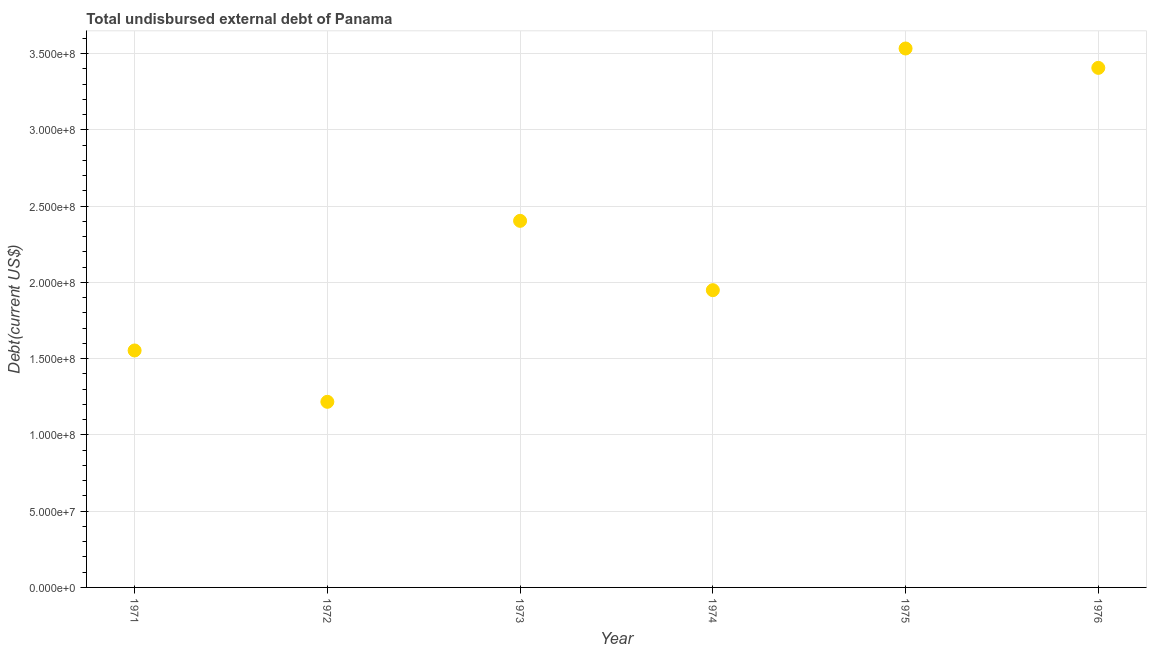What is the total debt in 1976?
Your answer should be very brief. 3.41e+08. Across all years, what is the maximum total debt?
Your answer should be compact. 3.53e+08. Across all years, what is the minimum total debt?
Your answer should be very brief. 1.22e+08. In which year was the total debt maximum?
Your answer should be compact. 1975. In which year was the total debt minimum?
Make the answer very short. 1972. What is the sum of the total debt?
Provide a short and direct response. 1.41e+09. What is the difference between the total debt in 1973 and 1976?
Give a very brief answer. -1.00e+08. What is the average total debt per year?
Offer a very short reply. 2.34e+08. What is the median total debt?
Ensure brevity in your answer.  2.18e+08. Do a majority of the years between 1974 and 1972 (inclusive) have total debt greater than 270000000 US$?
Ensure brevity in your answer.  No. What is the ratio of the total debt in 1973 to that in 1976?
Offer a very short reply. 0.71. Is the difference between the total debt in 1974 and 1975 greater than the difference between any two years?
Keep it short and to the point. No. What is the difference between the highest and the second highest total debt?
Offer a terse response. 1.27e+07. What is the difference between the highest and the lowest total debt?
Keep it short and to the point. 2.32e+08. In how many years, is the total debt greater than the average total debt taken over all years?
Your answer should be compact. 3. How many years are there in the graph?
Your response must be concise. 6. What is the difference between two consecutive major ticks on the Y-axis?
Your answer should be compact. 5.00e+07. Does the graph contain any zero values?
Offer a terse response. No. Does the graph contain grids?
Give a very brief answer. Yes. What is the title of the graph?
Your answer should be very brief. Total undisbursed external debt of Panama. What is the label or title of the Y-axis?
Give a very brief answer. Debt(current US$). What is the Debt(current US$) in 1971?
Keep it short and to the point. 1.55e+08. What is the Debt(current US$) in 1972?
Keep it short and to the point. 1.22e+08. What is the Debt(current US$) in 1973?
Your answer should be very brief. 2.40e+08. What is the Debt(current US$) in 1974?
Your answer should be very brief. 1.95e+08. What is the Debt(current US$) in 1975?
Offer a very short reply. 3.53e+08. What is the Debt(current US$) in 1976?
Your answer should be compact. 3.41e+08. What is the difference between the Debt(current US$) in 1971 and 1972?
Make the answer very short. 3.37e+07. What is the difference between the Debt(current US$) in 1971 and 1973?
Make the answer very short. -8.50e+07. What is the difference between the Debt(current US$) in 1971 and 1974?
Provide a short and direct response. -3.95e+07. What is the difference between the Debt(current US$) in 1971 and 1975?
Offer a very short reply. -1.98e+08. What is the difference between the Debt(current US$) in 1971 and 1976?
Your answer should be compact. -1.85e+08. What is the difference between the Debt(current US$) in 1972 and 1973?
Your response must be concise. -1.19e+08. What is the difference between the Debt(current US$) in 1972 and 1974?
Offer a terse response. -7.32e+07. What is the difference between the Debt(current US$) in 1972 and 1975?
Provide a succinct answer. -2.32e+08. What is the difference between the Debt(current US$) in 1972 and 1976?
Give a very brief answer. -2.19e+08. What is the difference between the Debt(current US$) in 1973 and 1974?
Your answer should be very brief. 4.54e+07. What is the difference between the Debt(current US$) in 1973 and 1975?
Ensure brevity in your answer.  -1.13e+08. What is the difference between the Debt(current US$) in 1973 and 1976?
Ensure brevity in your answer.  -1.00e+08. What is the difference between the Debt(current US$) in 1974 and 1975?
Offer a terse response. -1.58e+08. What is the difference between the Debt(current US$) in 1974 and 1976?
Ensure brevity in your answer.  -1.46e+08. What is the difference between the Debt(current US$) in 1975 and 1976?
Offer a very short reply. 1.27e+07. What is the ratio of the Debt(current US$) in 1971 to that in 1972?
Give a very brief answer. 1.28. What is the ratio of the Debt(current US$) in 1971 to that in 1973?
Your answer should be compact. 0.65. What is the ratio of the Debt(current US$) in 1971 to that in 1974?
Offer a terse response. 0.8. What is the ratio of the Debt(current US$) in 1971 to that in 1975?
Provide a succinct answer. 0.44. What is the ratio of the Debt(current US$) in 1971 to that in 1976?
Ensure brevity in your answer.  0.46. What is the ratio of the Debt(current US$) in 1972 to that in 1973?
Provide a succinct answer. 0.51. What is the ratio of the Debt(current US$) in 1972 to that in 1974?
Offer a very short reply. 0.62. What is the ratio of the Debt(current US$) in 1972 to that in 1975?
Keep it short and to the point. 0.34. What is the ratio of the Debt(current US$) in 1972 to that in 1976?
Keep it short and to the point. 0.36. What is the ratio of the Debt(current US$) in 1973 to that in 1974?
Give a very brief answer. 1.23. What is the ratio of the Debt(current US$) in 1973 to that in 1975?
Your answer should be compact. 0.68. What is the ratio of the Debt(current US$) in 1973 to that in 1976?
Give a very brief answer. 0.71. What is the ratio of the Debt(current US$) in 1974 to that in 1975?
Give a very brief answer. 0.55. What is the ratio of the Debt(current US$) in 1974 to that in 1976?
Offer a very short reply. 0.57. 